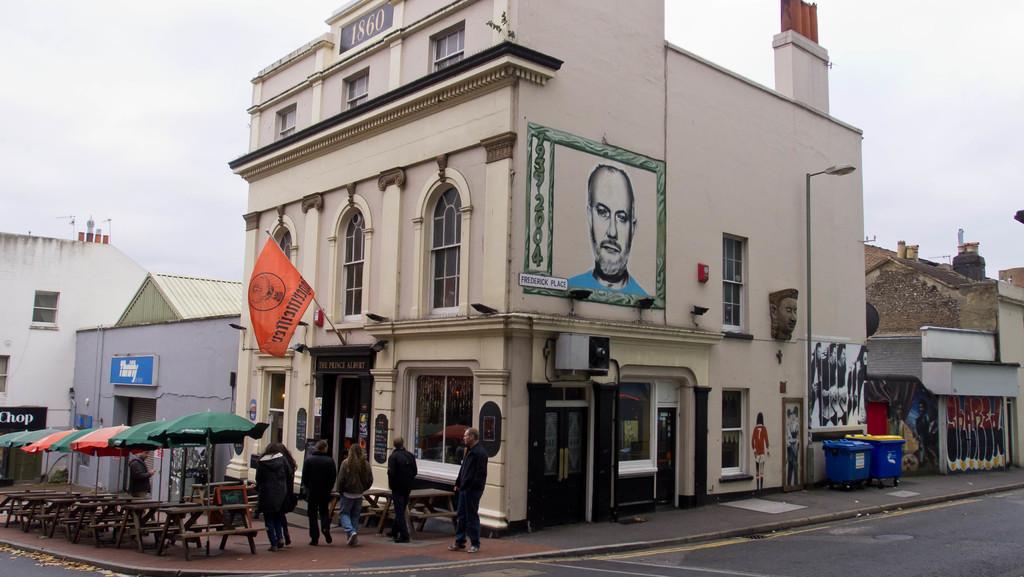Can you describe this image briefly? In this image we can see some people walking on the path, there are some buildings, doors, windows, also we can see few people's images on the walls, there are some umbrellas, tables, chairs, a light pole, also we can see the flag and the sky. 